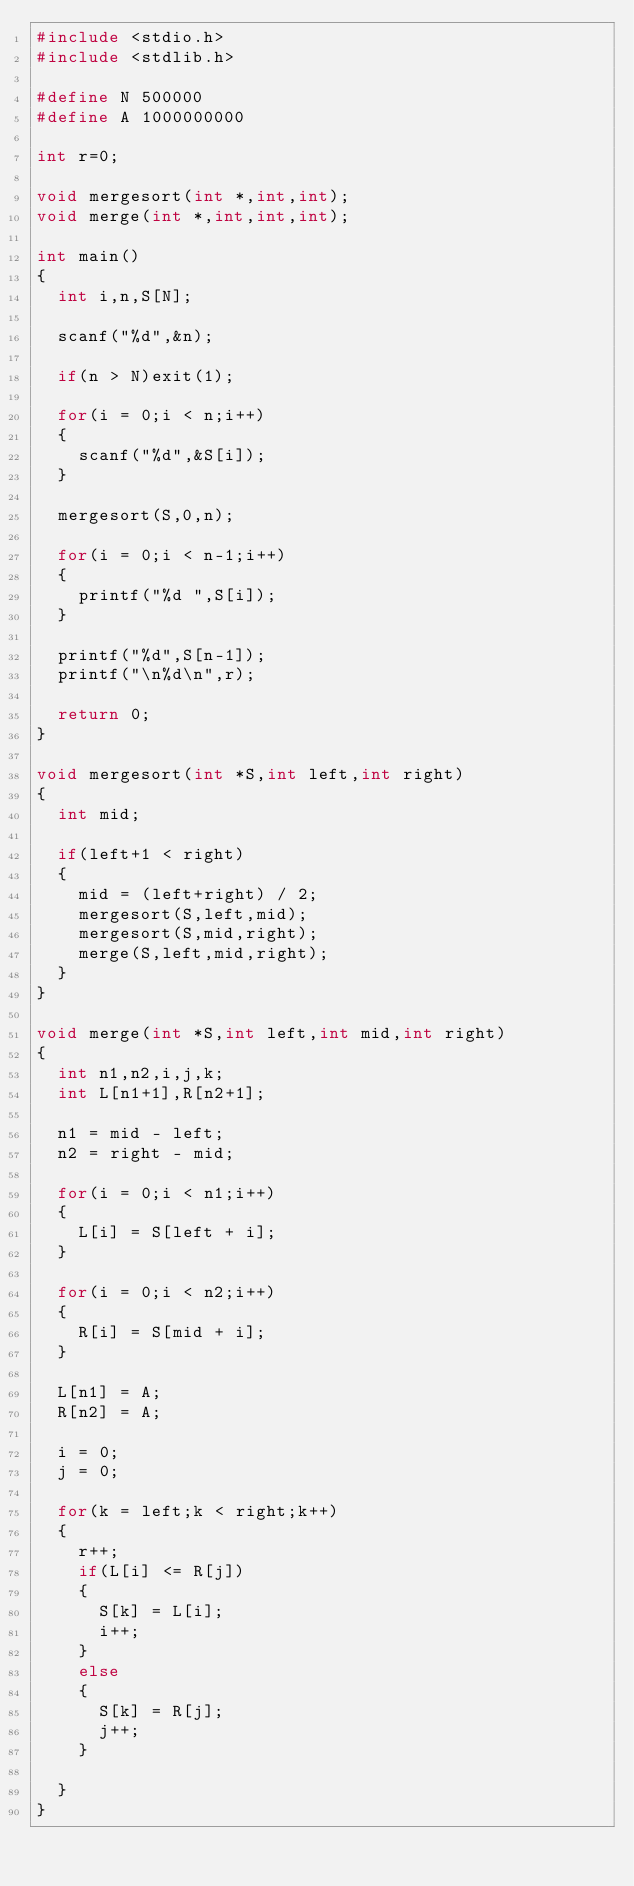Convert code to text. <code><loc_0><loc_0><loc_500><loc_500><_C_>#include <stdio.h>
#include <stdlib.h>

#define N 500000
#define A 1000000000

int r=0;

void mergesort(int *,int,int);
void merge(int *,int,int,int);

int main()
{
  int i,n,S[N];

  scanf("%d",&n); 

  if(n > N)exit(1);

  for(i = 0;i < n;i++)
  {
    scanf("%d",&S[i]);
  }

  mergesort(S,0,n);

  for(i = 0;i < n-1;i++)
  {
    printf("%d ",S[i]);
  }

  printf("%d",S[n-1]);
  printf("\n%d\n",r);

  return 0;
}

void mergesort(int *S,int left,int right)
{
  int mid;

  if(left+1 < right)
  {
    mid = (left+right) / 2;
    mergesort(S,left,mid);
    mergesort(S,mid,right);
    merge(S,left,mid,right);
  }
}

void merge(int *S,int left,int mid,int right)
{
  int n1,n2,i,j,k;
  int L[n1+1],R[n2+1];

  n1 = mid - left;
  n2 = right - mid;

  for(i = 0;i < n1;i++)
  {
    L[i] = S[left + i];
  }

  for(i = 0;i < n2;i++)
  {
    R[i] = S[mid + i];
  }

  L[n1] = A;
  R[n2] = A;

  i = 0;
  j = 0;

  for(k = left;k < right;k++)
  {
    r++;
    if(L[i] <= R[j])
    {
      S[k] = L[i];
      i++;
    }
    else
    {
      S[k] = R[j];
      j++;
    }

  }
}</code> 